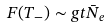Convert formula to latex. <formula><loc_0><loc_0><loc_500><loc_500>F ( T _ { - } ) \sim g t \bar { N } _ { e }</formula> 